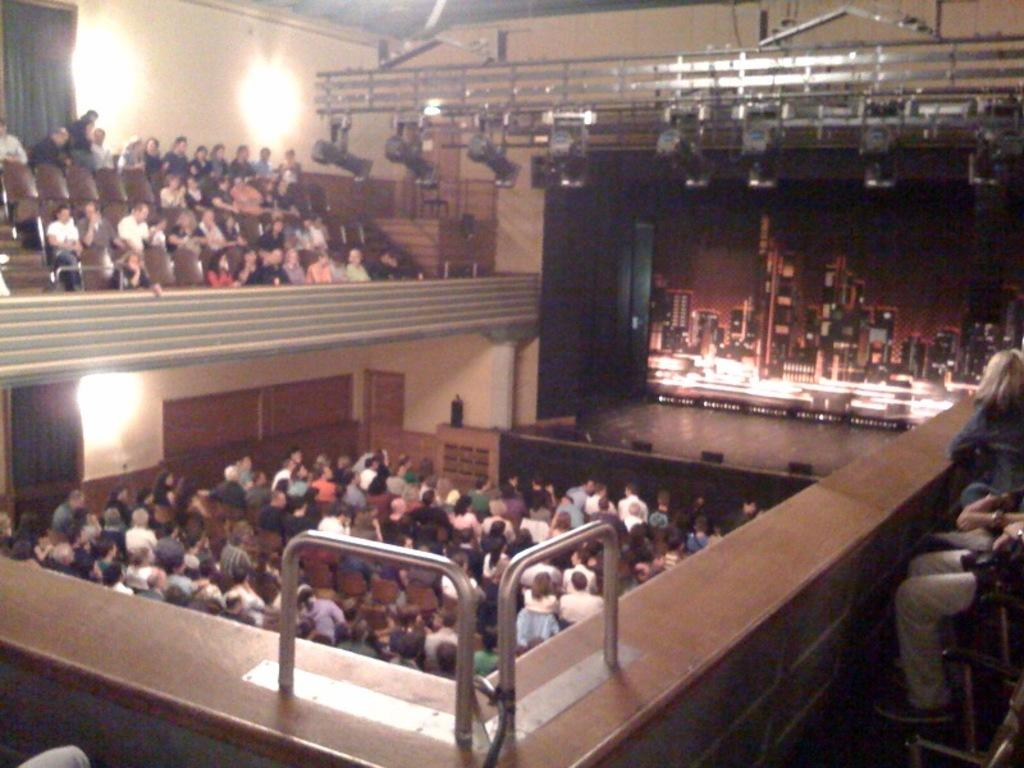What are the people in the image doing? The people in the image are sitting on chairs. What can be seen in the background of the image? There is a stage, a screen, and focusing lights in the background. What objects are present in the foreground of the image? There is a wall and rods in the foreground of the image. What type of arithmetic problem is being solved on the screen in the background? There is no arithmetic problem visible on the screen in the image. What type of machine is being used by the people sitting on chairs? There is no machine present in the image; the people are simply sitting on chairs. 